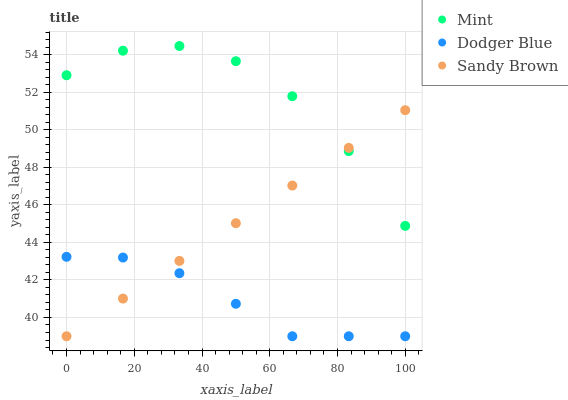Does Dodger Blue have the minimum area under the curve?
Answer yes or no. Yes. Does Mint have the maximum area under the curve?
Answer yes or no. Yes. Does Sandy Brown have the minimum area under the curve?
Answer yes or no. No. Does Sandy Brown have the maximum area under the curve?
Answer yes or no. No. Is Sandy Brown the smoothest?
Answer yes or no. Yes. Is Mint the roughest?
Answer yes or no. Yes. Is Mint the smoothest?
Answer yes or no. No. Is Sandy Brown the roughest?
Answer yes or no. No. Does Dodger Blue have the lowest value?
Answer yes or no. Yes. Does Mint have the lowest value?
Answer yes or no. No. Does Mint have the highest value?
Answer yes or no. Yes. Does Sandy Brown have the highest value?
Answer yes or no. No. Is Dodger Blue less than Mint?
Answer yes or no. Yes. Is Mint greater than Dodger Blue?
Answer yes or no. Yes. Does Sandy Brown intersect Mint?
Answer yes or no. Yes. Is Sandy Brown less than Mint?
Answer yes or no. No. Is Sandy Brown greater than Mint?
Answer yes or no. No. Does Dodger Blue intersect Mint?
Answer yes or no. No. 